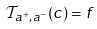Convert formula to latex. <formula><loc_0><loc_0><loc_500><loc_500>\mathcal { T } _ { a ^ { + } , a ^ { - } } ( c ) = f</formula> 